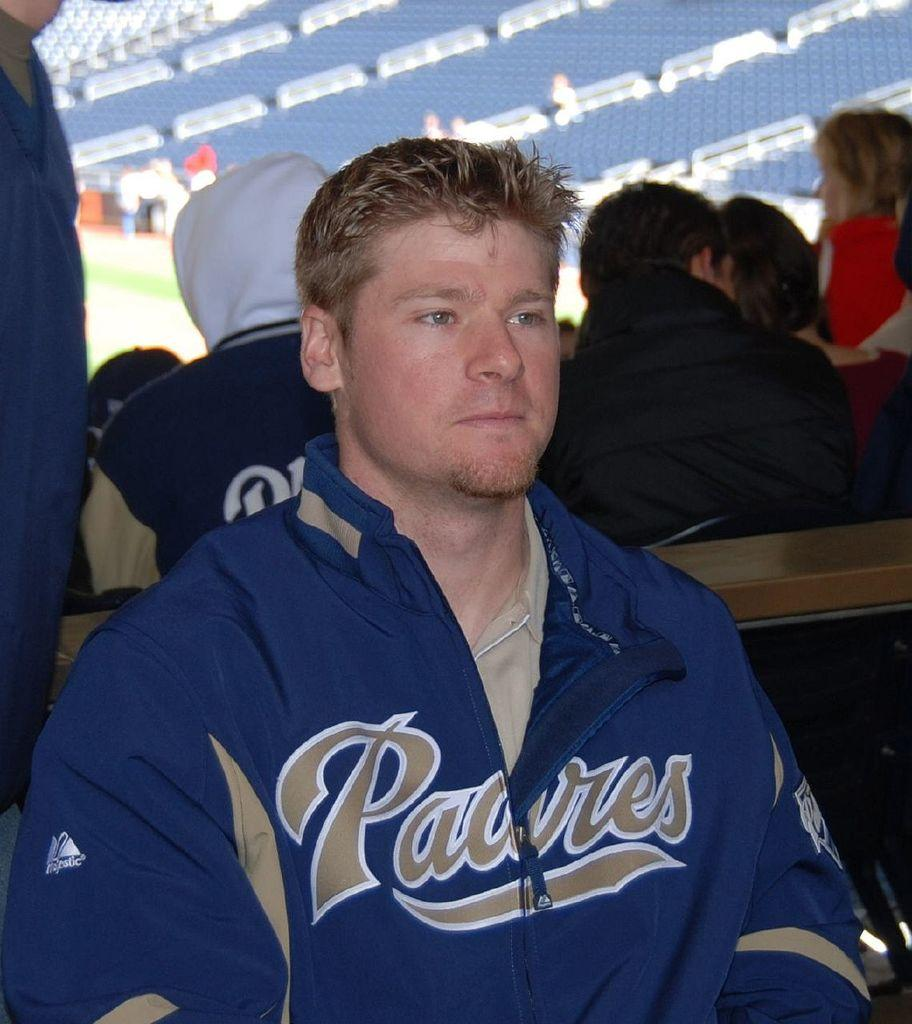Who is the main subject in the image? There is a man in the center of the image. What are the people in the background doing? There are people sitting on chairs in the background. Can you describe the person on the left side of the image? There is a person standing on the left side of the image. What structures can be seen in the image? There are stands visible in the image. What type of alley can be seen behind the man in the image? There is no alley visible in the image; it is not mentioned in the provided facts. 